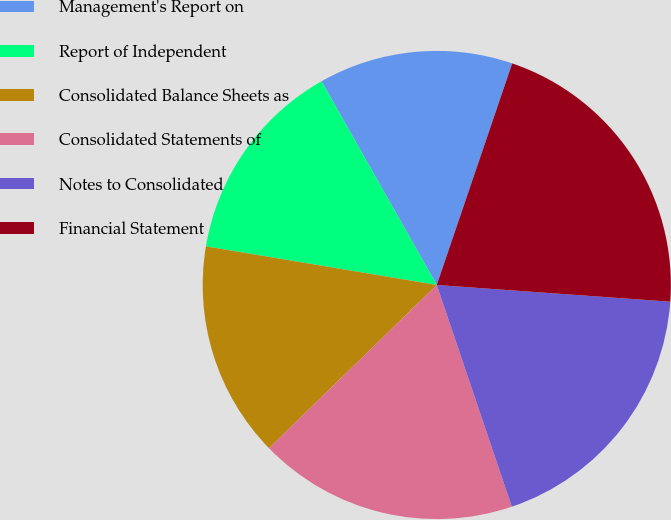Convert chart. <chart><loc_0><loc_0><loc_500><loc_500><pie_chart><fcel>Management's Report on<fcel>Report of Independent<fcel>Consolidated Balance Sheets as<fcel>Consolidated Statements of<fcel>Notes to Consolidated<fcel>Financial Statement<nl><fcel>13.42%<fcel>14.17%<fcel>14.92%<fcel>17.92%<fcel>18.67%<fcel>20.92%<nl></chart> 